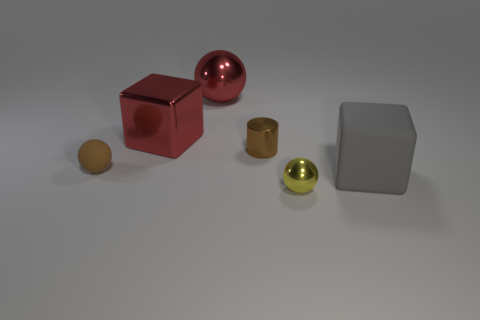What might be the function of the metallic cylindrical object, and is it usually found indoors or outdoors? The metallic cylindrical object appears to be a container of some sort, possibly used for storing small items. Given its clean and shiny appearance, it is likely to be found indoors as a decorative or functional piece in a home or office setting. 